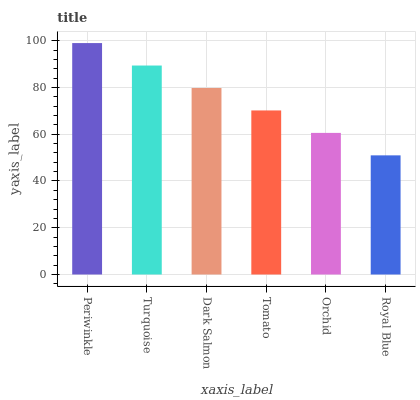Is Royal Blue the minimum?
Answer yes or no. Yes. Is Periwinkle the maximum?
Answer yes or no. Yes. Is Turquoise the minimum?
Answer yes or no. No. Is Turquoise the maximum?
Answer yes or no. No. Is Periwinkle greater than Turquoise?
Answer yes or no. Yes. Is Turquoise less than Periwinkle?
Answer yes or no. Yes. Is Turquoise greater than Periwinkle?
Answer yes or no. No. Is Periwinkle less than Turquoise?
Answer yes or no. No. Is Dark Salmon the high median?
Answer yes or no. Yes. Is Tomato the low median?
Answer yes or no. Yes. Is Tomato the high median?
Answer yes or no. No. Is Royal Blue the low median?
Answer yes or no. No. 